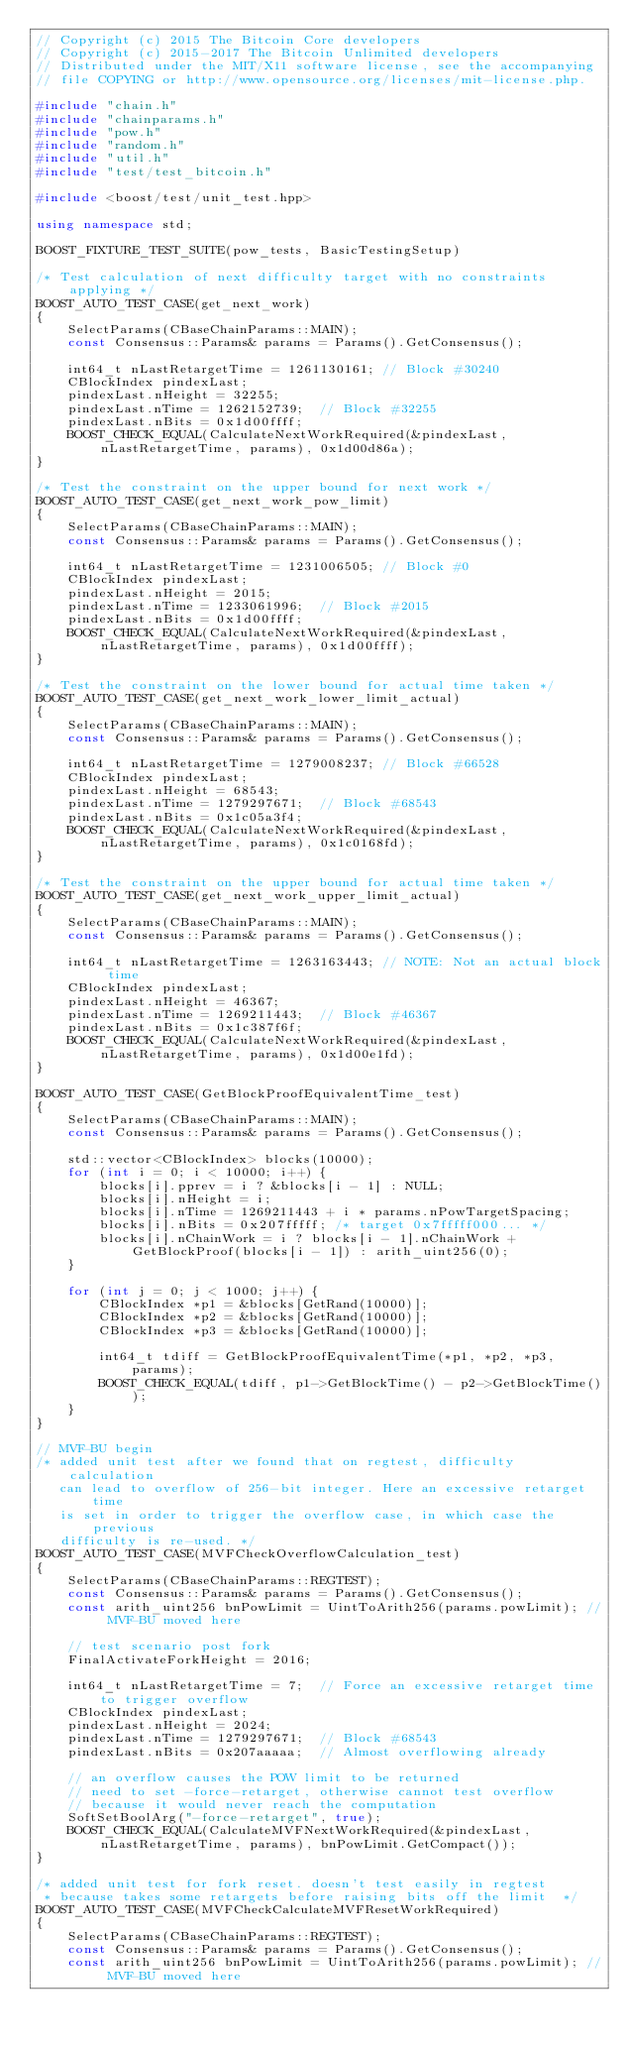Convert code to text. <code><loc_0><loc_0><loc_500><loc_500><_C++_>// Copyright (c) 2015 The Bitcoin Core developers
// Copyright (c) 2015-2017 The Bitcoin Unlimited developers
// Distributed under the MIT/X11 software license, see the accompanying
// file COPYING or http://www.opensource.org/licenses/mit-license.php.

#include "chain.h"
#include "chainparams.h"
#include "pow.h"
#include "random.h"
#include "util.h"
#include "test/test_bitcoin.h"

#include <boost/test/unit_test.hpp>

using namespace std;

BOOST_FIXTURE_TEST_SUITE(pow_tests, BasicTestingSetup)

/* Test calculation of next difficulty target with no constraints applying */
BOOST_AUTO_TEST_CASE(get_next_work)
{
    SelectParams(CBaseChainParams::MAIN);
    const Consensus::Params& params = Params().GetConsensus();

    int64_t nLastRetargetTime = 1261130161; // Block #30240
    CBlockIndex pindexLast;
    pindexLast.nHeight = 32255;
    pindexLast.nTime = 1262152739;  // Block #32255
    pindexLast.nBits = 0x1d00ffff;
    BOOST_CHECK_EQUAL(CalculateNextWorkRequired(&pindexLast, nLastRetargetTime, params), 0x1d00d86a);
}

/* Test the constraint on the upper bound for next work */
BOOST_AUTO_TEST_CASE(get_next_work_pow_limit)
{
    SelectParams(CBaseChainParams::MAIN);
    const Consensus::Params& params = Params().GetConsensus();

    int64_t nLastRetargetTime = 1231006505; // Block #0
    CBlockIndex pindexLast;
    pindexLast.nHeight = 2015;
    pindexLast.nTime = 1233061996;  // Block #2015
    pindexLast.nBits = 0x1d00ffff;
    BOOST_CHECK_EQUAL(CalculateNextWorkRequired(&pindexLast, nLastRetargetTime, params), 0x1d00ffff);
}

/* Test the constraint on the lower bound for actual time taken */
BOOST_AUTO_TEST_CASE(get_next_work_lower_limit_actual)
{
    SelectParams(CBaseChainParams::MAIN);
    const Consensus::Params& params = Params().GetConsensus();

    int64_t nLastRetargetTime = 1279008237; // Block #66528
    CBlockIndex pindexLast;
    pindexLast.nHeight = 68543;
    pindexLast.nTime = 1279297671;  // Block #68543
    pindexLast.nBits = 0x1c05a3f4;
    BOOST_CHECK_EQUAL(CalculateNextWorkRequired(&pindexLast, nLastRetargetTime, params), 0x1c0168fd);
}

/* Test the constraint on the upper bound for actual time taken */
BOOST_AUTO_TEST_CASE(get_next_work_upper_limit_actual)
{
    SelectParams(CBaseChainParams::MAIN);
    const Consensus::Params& params = Params().GetConsensus();

    int64_t nLastRetargetTime = 1263163443; // NOTE: Not an actual block time
    CBlockIndex pindexLast;
    pindexLast.nHeight = 46367;
    pindexLast.nTime = 1269211443;  // Block #46367
    pindexLast.nBits = 0x1c387f6f;
    BOOST_CHECK_EQUAL(CalculateNextWorkRequired(&pindexLast, nLastRetargetTime, params), 0x1d00e1fd);
}

BOOST_AUTO_TEST_CASE(GetBlockProofEquivalentTime_test)
{
    SelectParams(CBaseChainParams::MAIN);
    const Consensus::Params& params = Params().GetConsensus();

    std::vector<CBlockIndex> blocks(10000);
    for (int i = 0; i < 10000; i++) {
        blocks[i].pprev = i ? &blocks[i - 1] : NULL;
        blocks[i].nHeight = i;
        blocks[i].nTime = 1269211443 + i * params.nPowTargetSpacing;
        blocks[i].nBits = 0x207fffff; /* target 0x7fffff000... */
        blocks[i].nChainWork = i ? blocks[i - 1].nChainWork + GetBlockProof(blocks[i - 1]) : arith_uint256(0);
    }

    for (int j = 0; j < 1000; j++) {
        CBlockIndex *p1 = &blocks[GetRand(10000)];
        CBlockIndex *p2 = &blocks[GetRand(10000)];
        CBlockIndex *p3 = &blocks[GetRand(10000)];

        int64_t tdiff = GetBlockProofEquivalentTime(*p1, *p2, *p3, params);
        BOOST_CHECK_EQUAL(tdiff, p1->GetBlockTime() - p2->GetBlockTime());
    }
}

// MVF-BU begin
/* added unit test after we found that on regtest, difficulty calculation
   can lead to overflow of 256-bit integer. Here an excessive retarget time
   is set in order to trigger the overflow case, in which case the previous
   difficulty is re-used. */
BOOST_AUTO_TEST_CASE(MVFCheckOverflowCalculation_test)
{
    SelectParams(CBaseChainParams::REGTEST);
    const Consensus::Params& params = Params().GetConsensus();
    const arith_uint256 bnPowLimit = UintToArith256(params.powLimit); // MVF-BU moved here

    // test scenario post fork
    FinalActivateForkHeight = 2016;

    int64_t nLastRetargetTime = 7;  // Force an excessive retarget time to trigger overflow
    CBlockIndex pindexLast;
    pindexLast.nHeight = 2024;
    pindexLast.nTime = 1279297671;  // Block #68543
    pindexLast.nBits = 0x207aaaaa;  // Almost overflowing already

    // an overflow causes the POW limit to be returned
    // need to set -force-retarget, otherwise cannot test overflow
    // because it would never reach the computation
    SoftSetBoolArg("-force-retarget", true);
    BOOST_CHECK_EQUAL(CalculateMVFNextWorkRequired(&pindexLast, nLastRetargetTime, params), bnPowLimit.GetCompact());
}

/* added unit test for fork reset. doesn't test easily in regtest
 * because takes some retargets before raising bits off the limit  */
BOOST_AUTO_TEST_CASE(MVFCheckCalculateMVFResetWorkRequired)
{
    SelectParams(CBaseChainParams::REGTEST);
    const Consensus::Params& params = Params().GetConsensus();
    const arith_uint256 bnPowLimit = UintToArith256(params.powLimit); // MVF-BU moved here
</code> 